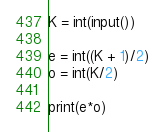<code> <loc_0><loc_0><loc_500><loc_500><_Python_>K = int(input())

e = int((K + 1)/2)
o = int(K/2)

print(e*o)</code> 